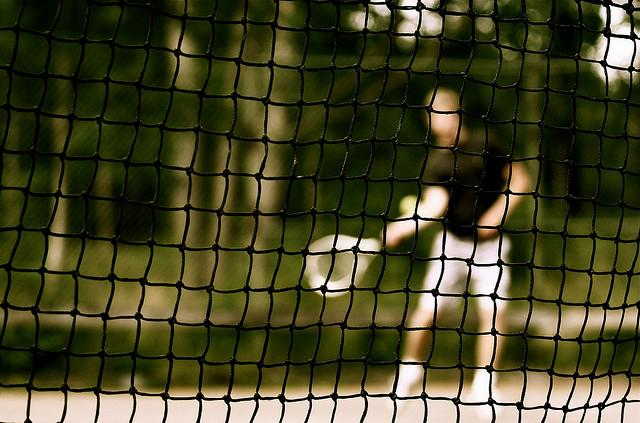This person is playing a similar sport to whom? Please explain your reasoning. serena williams. The man is holding a racket on a tennis court. 